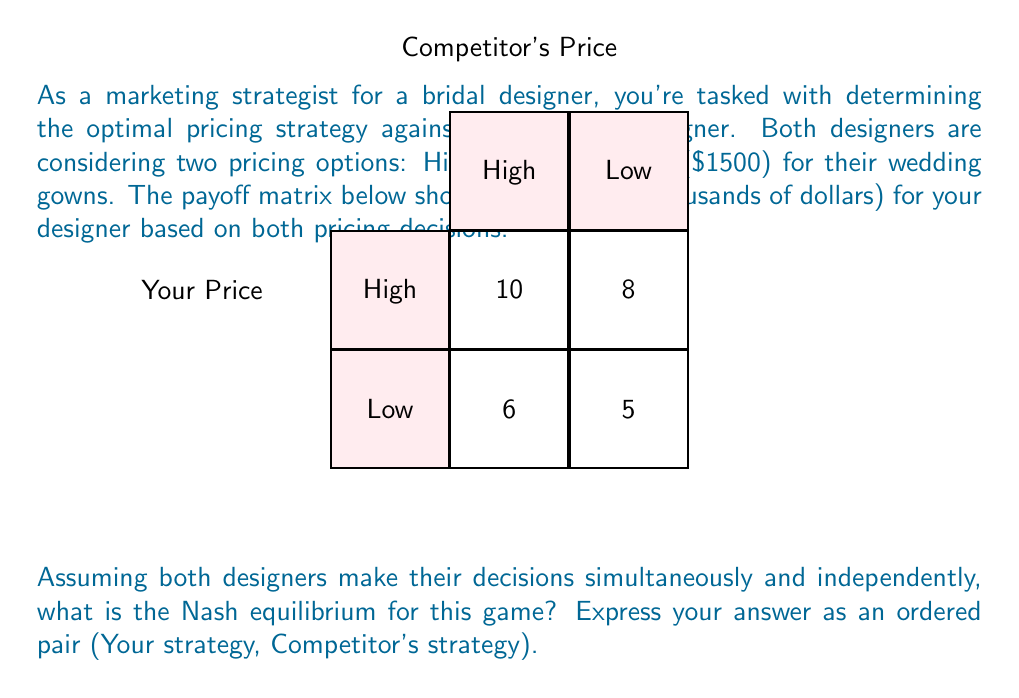Can you solve this math problem? To find the Nash equilibrium, we need to determine the best response for each player given the other player's strategy. Let's analyze this step-by-step:

1. From your perspective:
   - If the competitor chooses High:
     - Your profit if you choose High: $10,000
     - Your profit if you choose Low: $6,000
     Best response: High
   - If the competitor chooses Low:
     - Your profit if you choose High: $8,000
     - Your profit if you choose Low: $5,000
     Best response: High

2. From the competitor's perspective:
   - If you choose High:
     - Their profit if they choose High: $10,000 (symmetric game)
     - Their profit if they choose Low: $8,000
     Best response: High
   - If you choose Low:
     - Their profit if they choose High: $6,000
     - Their profit if they choose Low: $5,000
     Best response: High

3. Nash equilibrium occurs when both players are playing their best response to the other player's strategy.

4. In this case, regardless of what the competitor does, your best strategy is always to choose High. Similarly, the competitor's best strategy is always to choose High.

5. Therefore, the Nash equilibrium is (High, High), where both designers choose the high pricing strategy.

This equilibrium represents a stable state where neither player has an incentive to unilaterally change their strategy.
Answer: (High, High) 